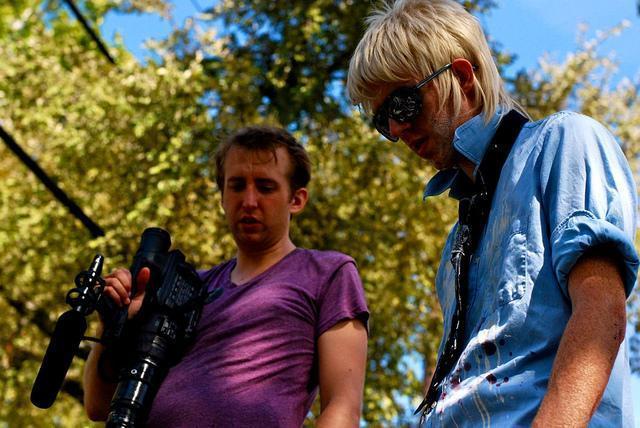How many people can be seen?
Give a very brief answer. 2. 